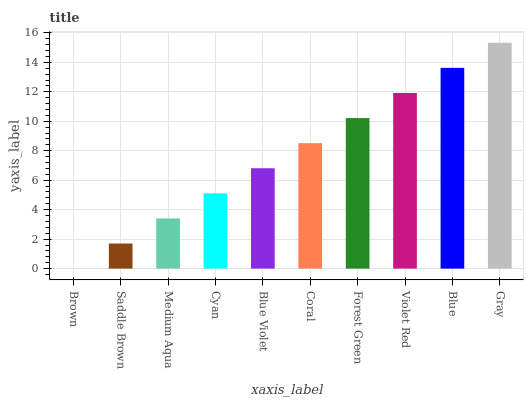Is Brown the minimum?
Answer yes or no. Yes. Is Gray the maximum?
Answer yes or no. Yes. Is Saddle Brown the minimum?
Answer yes or no. No. Is Saddle Brown the maximum?
Answer yes or no. No. Is Saddle Brown greater than Brown?
Answer yes or no. Yes. Is Brown less than Saddle Brown?
Answer yes or no. Yes. Is Brown greater than Saddle Brown?
Answer yes or no. No. Is Saddle Brown less than Brown?
Answer yes or no. No. Is Coral the high median?
Answer yes or no. Yes. Is Blue Violet the low median?
Answer yes or no. Yes. Is Violet Red the high median?
Answer yes or no. No. Is Brown the low median?
Answer yes or no. No. 